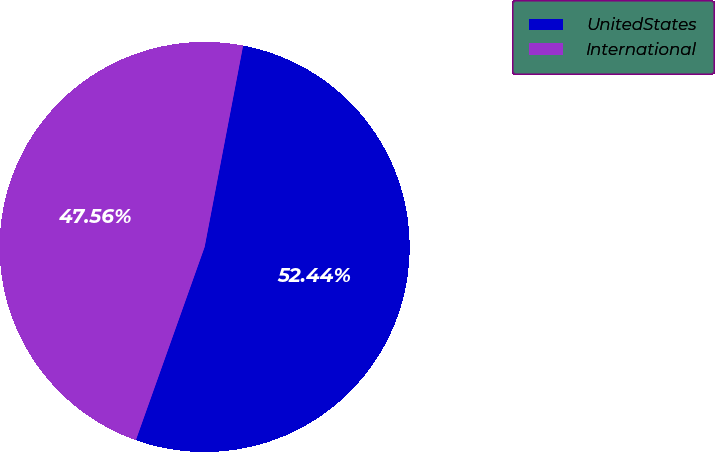<chart> <loc_0><loc_0><loc_500><loc_500><pie_chart><fcel>UnitedStates<fcel>International<nl><fcel>52.44%<fcel>47.56%<nl></chart> 